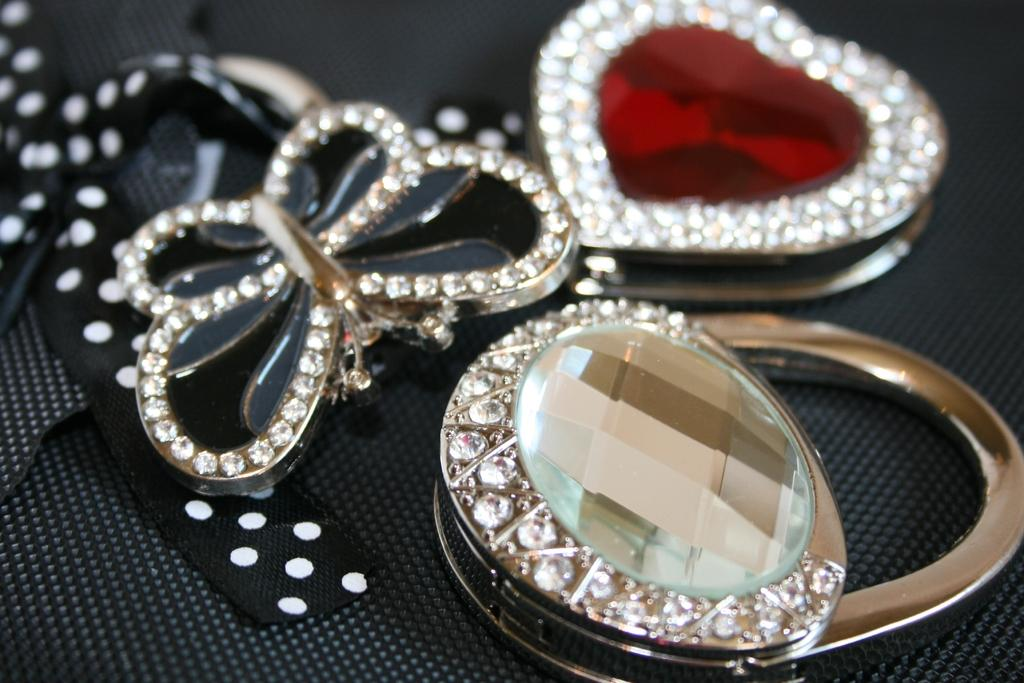How many pendants are visible in the image? There are three pendants in the image. Where are the pendants located? The pendants are on a platform. What type of car is parked next to the pendants in the image? There is no car present in the image; it only features three pendants on a platform. What is the purpose of the pendants in the image? The purpose of the pendants cannot be determined from the image alone, as it only shows their presence and location. 